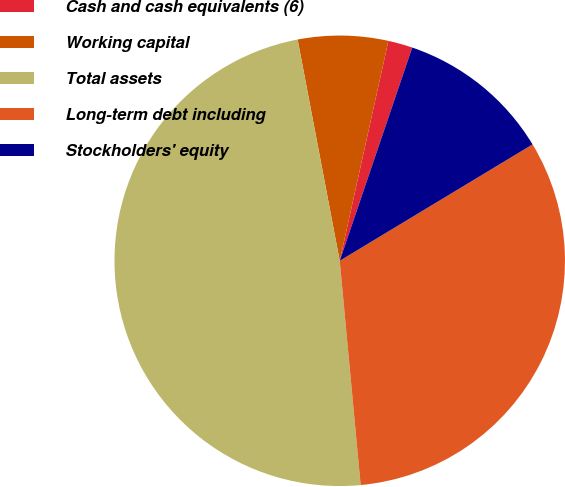Convert chart. <chart><loc_0><loc_0><loc_500><loc_500><pie_chart><fcel>Cash and cash equivalents (6)<fcel>Working capital<fcel>Total assets<fcel>Long-term debt including<fcel>Stockholders' equity<nl><fcel>1.75%<fcel>6.46%<fcel>48.49%<fcel>32.16%<fcel>11.14%<nl></chart> 